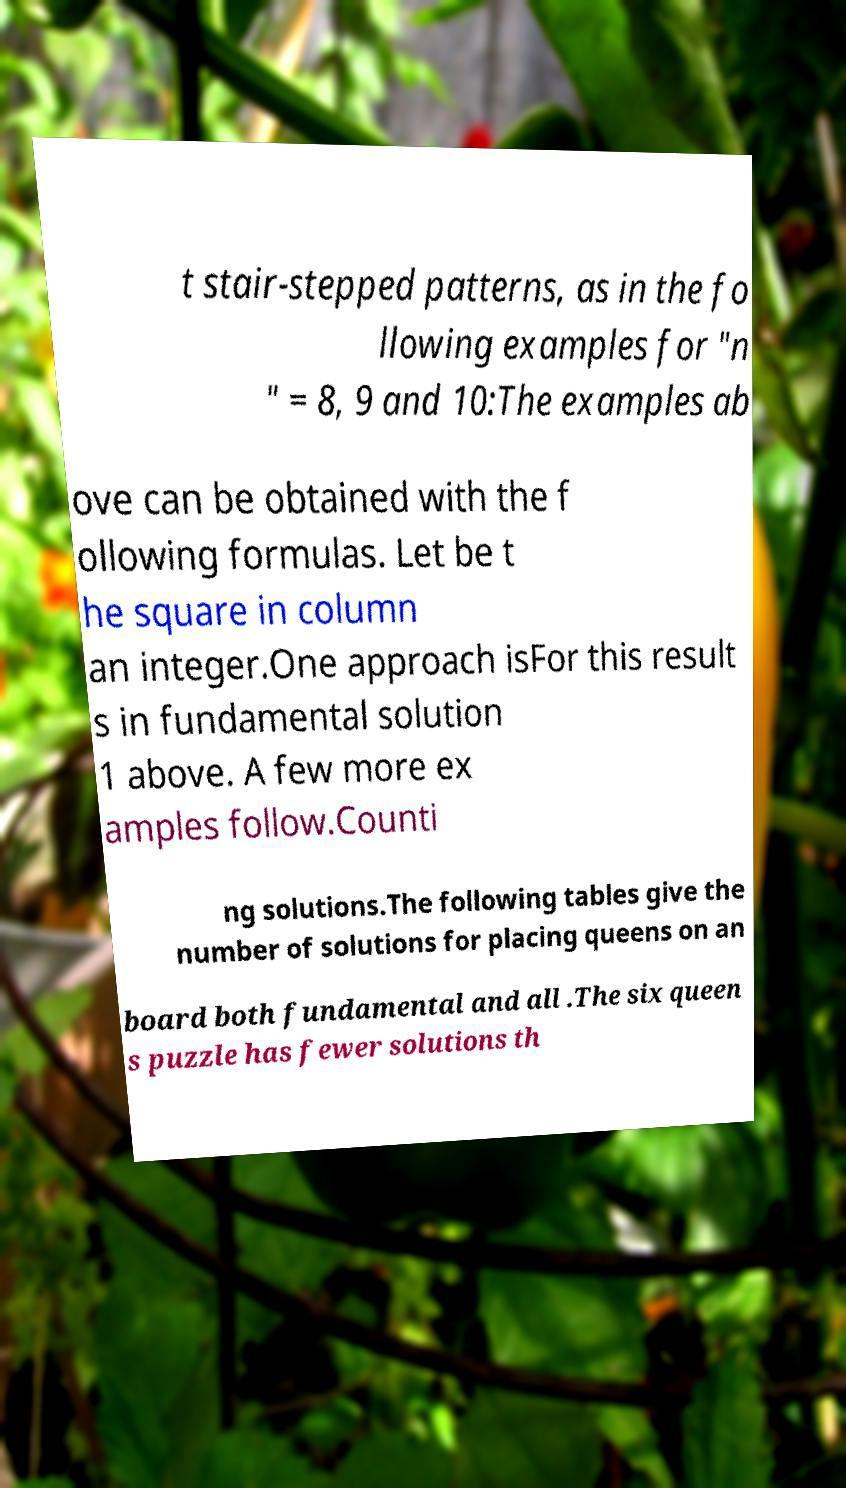What messages or text are displayed in this image? I need them in a readable, typed format. t stair-stepped patterns, as in the fo llowing examples for "n " = 8, 9 and 10:The examples ab ove can be obtained with the f ollowing formulas. Let be t he square in column an integer.One approach isFor this result s in fundamental solution 1 above. A few more ex amples follow.Counti ng solutions.The following tables give the number of solutions for placing queens on an board both fundamental and all .The six queen s puzzle has fewer solutions th 